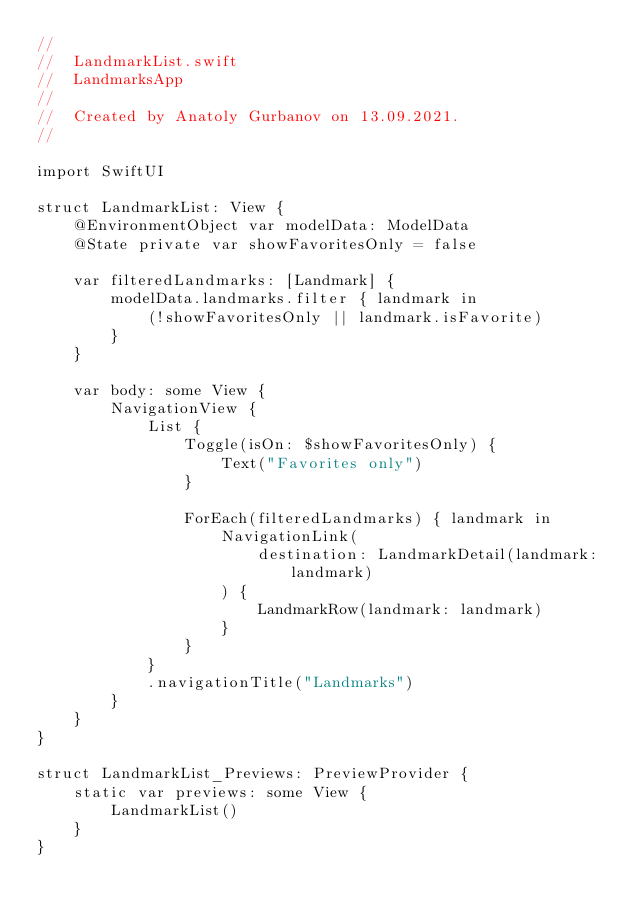<code> <loc_0><loc_0><loc_500><loc_500><_Swift_>//
//  LandmarkList.swift
//  LandmarksApp
//
//  Created by Anatoly Gurbanov on 13.09.2021.
//

import SwiftUI

struct LandmarkList: View {
    @EnvironmentObject var modelData: ModelData
    @State private var showFavoritesOnly = false

    var filteredLandmarks: [Landmark] {
        modelData.landmarks.filter { landmark in
            (!showFavoritesOnly || landmark.isFavorite)
        }
    }

    var body: some View {
        NavigationView {
            List {
                Toggle(isOn: $showFavoritesOnly) {
                    Text("Favorites only")
                }

                ForEach(filteredLandmarks) { landmark in
                    NavigationLink(
                        destination: LandmarkDetail(landmark: landmark)
                    ) {
                        LandmarkRow(landmark: landmark)
                    }
                }
            }
            .navigationTitle("Landmarks")
        }
    }
}

struct LandmarkList_Previews: PreviewProvider {
    static var previews: some View {
        LandmarkList()
    }
}
</code> 